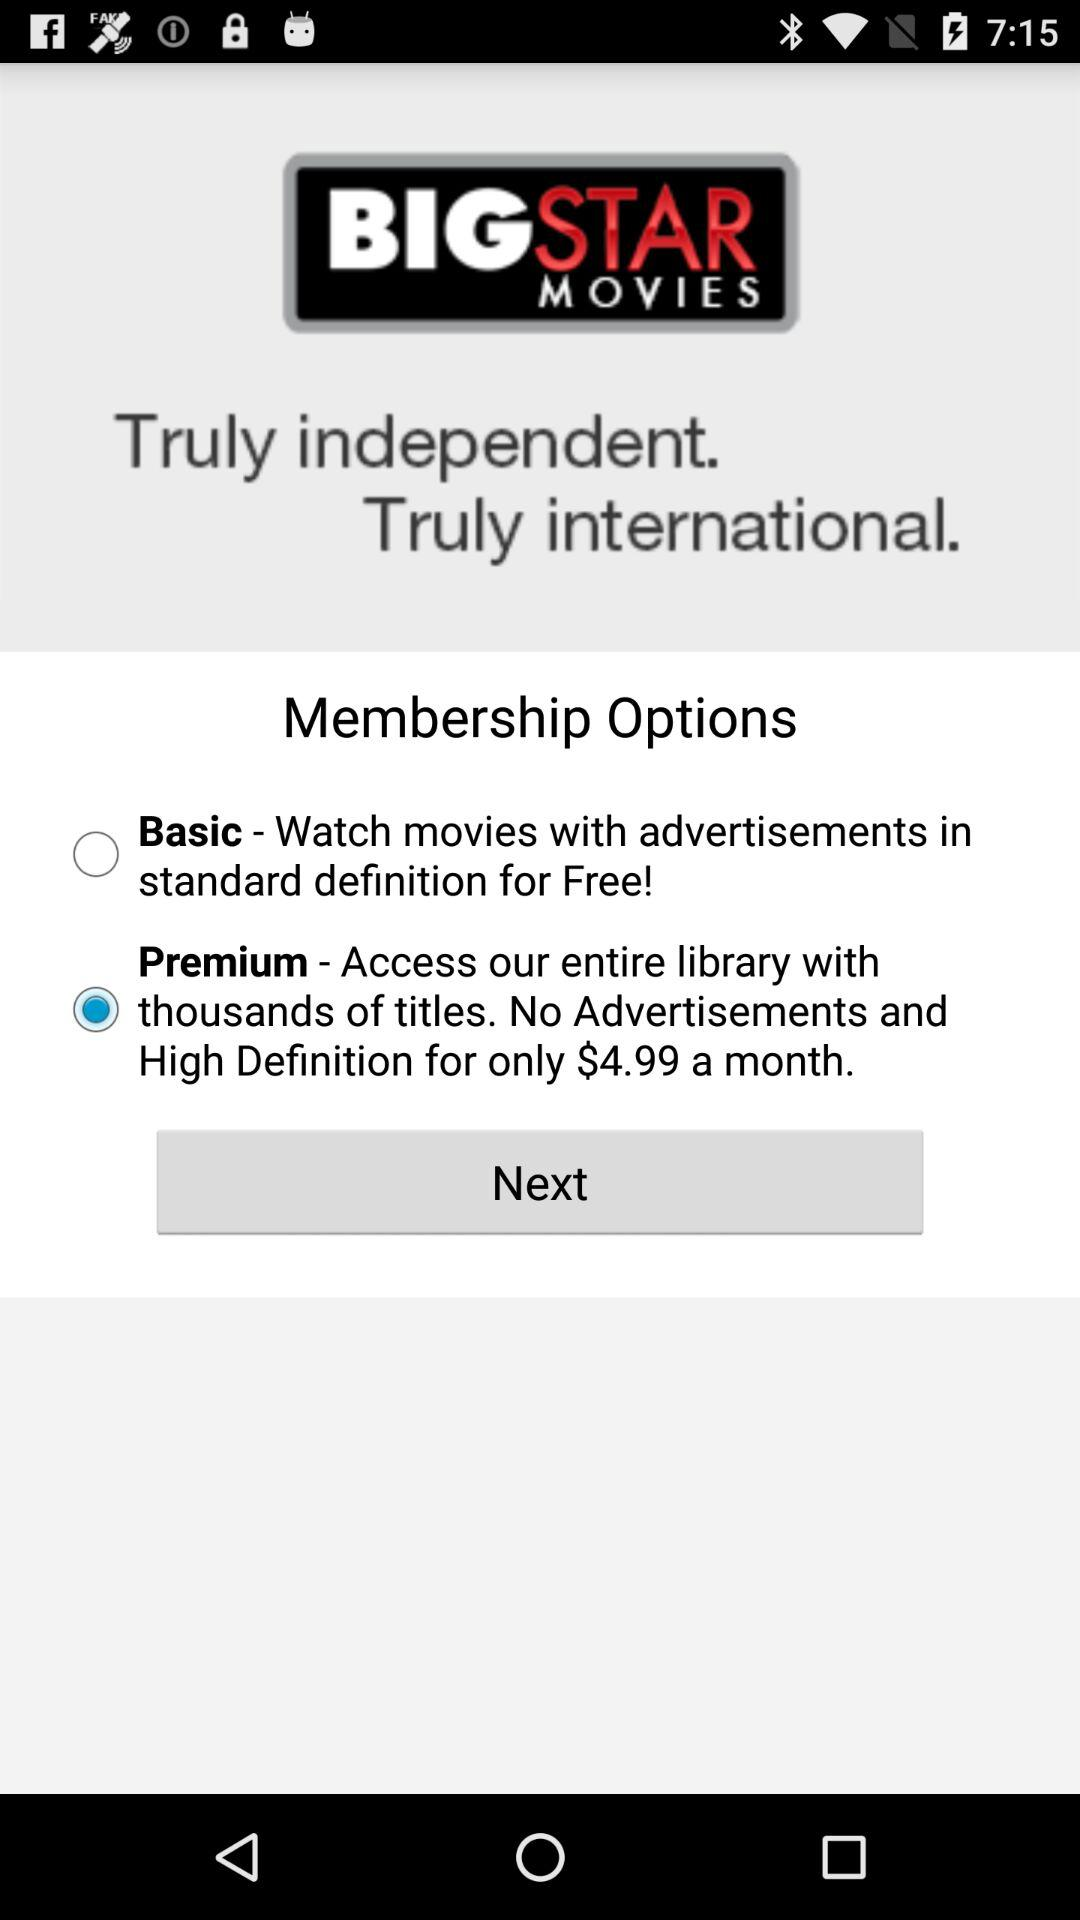Which membership option was selected? The selected membership option was "Premium". 